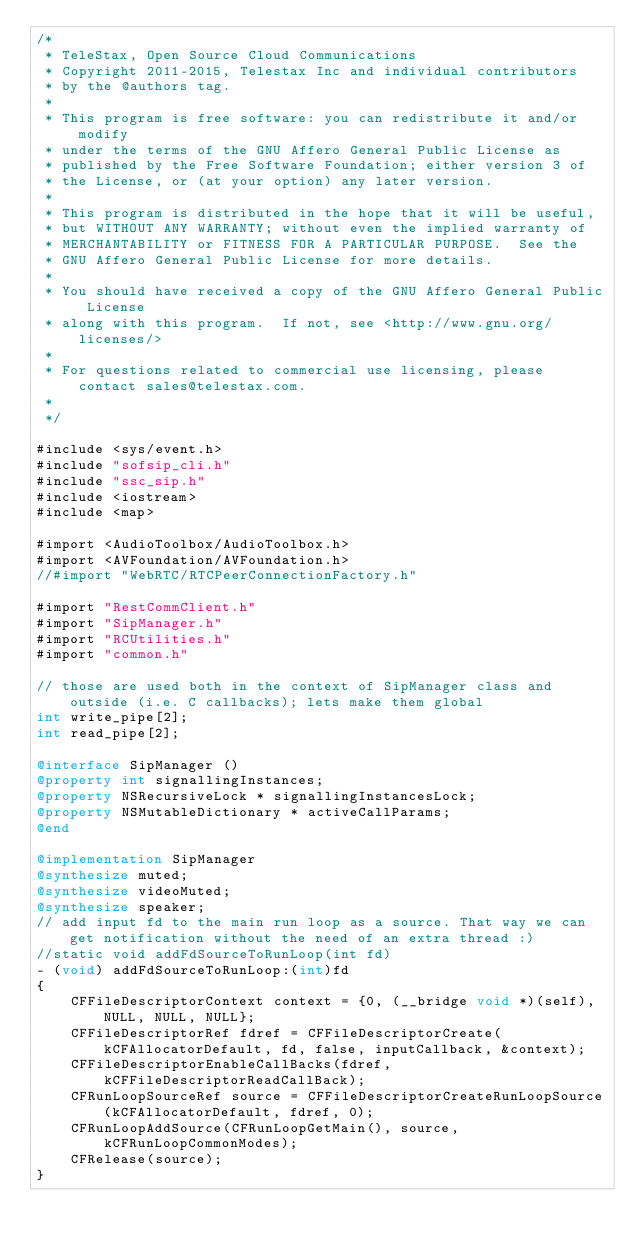Convert code to text. <code><loc_0><loc_0><loc_500><loc_500><_ObjectiveC_>/*
 * TeleStax, Open Source Cloud Communications
 * Copyright 2011-2015, Telestax Inc and individual contributors
 * by the @authors tag.
 *
 * This program is free software: you can redistribute it and/or modify
 * under the terms of the GNU Affero General Public License as
 * published by the Free Software Foundation; either version 3 of
 * the License, or (at your option) any later version.
 *
 * This program is distributed in the hope that it will be useful,
 * but WITHOUT ANY WARRANTY; without even the implied warranty of
 * MERCHANTABILITY or FITNESS FOR A PARTICULAR PURPOSE.  See the
 * GNU Affero General Public License for more details.
 *
 * You should have received a copy of the GNU Affero General Public License
 * along with this program.  If not, see <http://www.gnu.org/licenses/>
 *
 * For questions related to commercial use licensing, please contact sales@telestax.com.
 *
 */

#include <sys/event.h>
#include "sofsip_cli.h"
#include "ssc_sip.h"
#include <iostream>
#include <map>

#import <AudioToolbox/AudioToolbox.h>
#import <AVFoundation/AVFoundation.h>
//#import "WebRTC/RTCPeerConnectionFactory.h"

#import "RestCommClient.h"
#import "SipManager.h"
#import "RCUtilities.h"
#import "common.h"

// those are used both in the context of SipManager class and outside (i.e. C callbacks); lets make them global
int write_pipe[2];
int read_pipe[2];

@interface SipManager ()
@property int signallingInstances;
@property NSRecursiveLock * signallingInstancesLock;
@property NSMutableDictionary * activeCallParams;
@end

@implementation SipManager
@synthesize muted;
@synthesize videoMuted;
@synthesize speaker;
// add input fd to the main run loop as a source. That way we can get notification without the need of an extra thread :)
//static void addFdSourceToRunLoop(int fd)
- (void) addFdSourceToRunLoop:(int)fd
{
    CFFileDescriptorContext context = {0, (__bridge void *)(self), NULL, NULL, NULL};
    CFFileDescriptorRef fdref = CFFileDescriptorCreate(kCFAllocatorDefault, fd, false, inputCallback, &context);
    CFFileDescriptorEnableCallBacks(fdref, kCFFileDescriptorReadCallBack);
    CFRunLoopSourceRef source = CFFileDescriptorCreateRunLoopSource(kCFAllocatorDefault, fdref, 0);
    CFRunLoopAddSource(CFRunLoopGetMain(), source, kCFRunLoopCommonModes);
    CFRelease(source);
}
</code> 